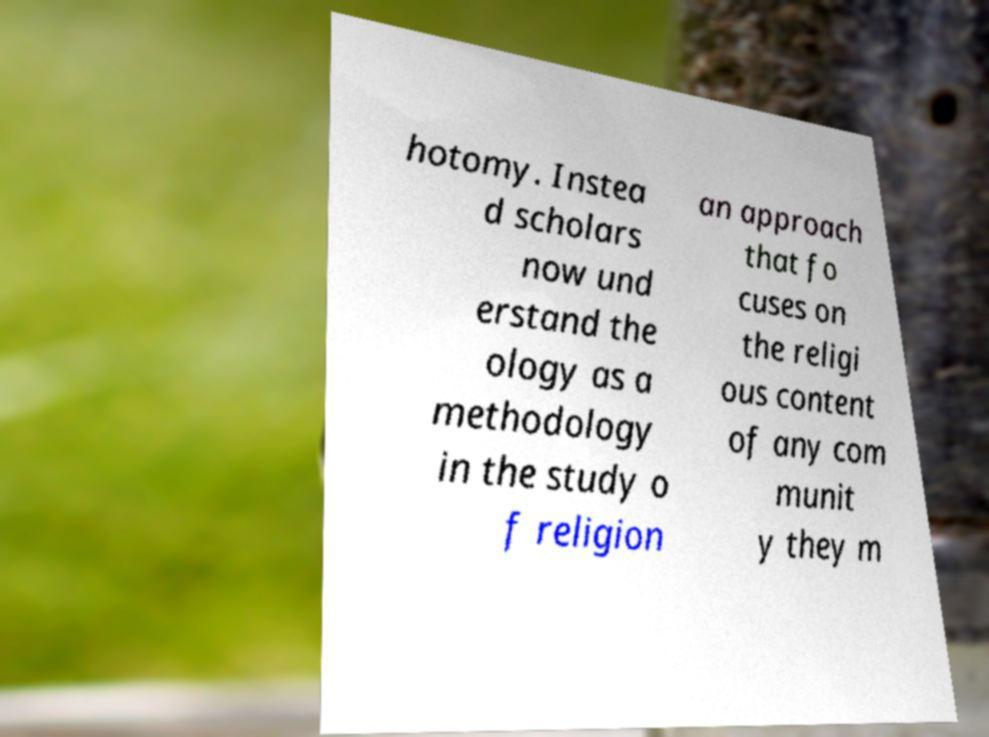Please read and relay the text visible in this image. What does it say? hotomy. Instea d scholars now und erstand the ology as a methodology in the study o f religion an approach that fo cuses on the religi ous content of any com munit y they m 